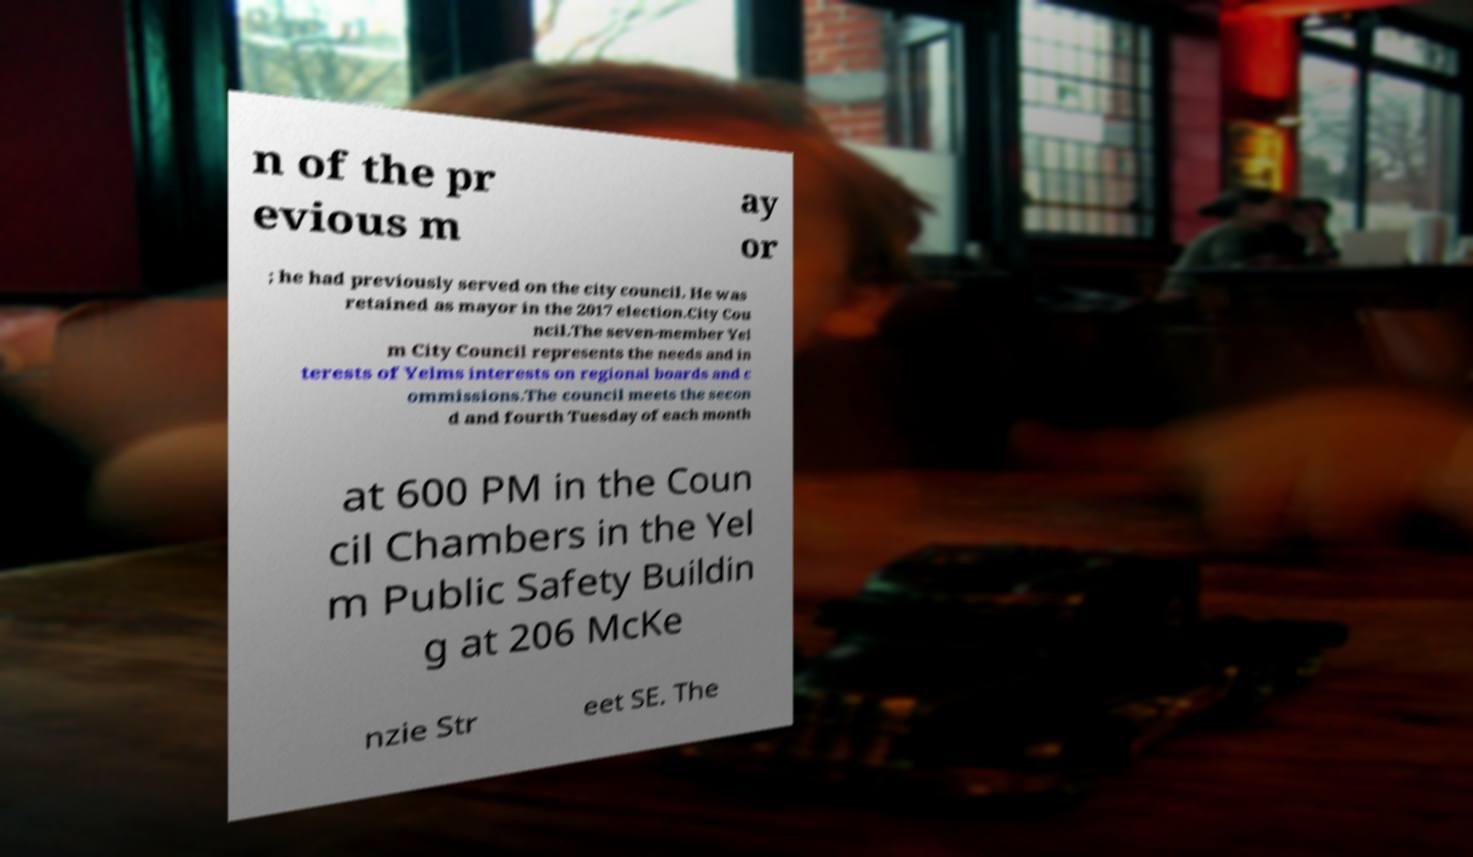Can you read and provide the text displayed in the image?This photo seems to have some interesting text. Can you extract and type it out for me? n of the pr evious m ay or ; he had previously served on the city council. He was retained as mayor in the 2017 election.City Cou ncil.The seven-member Yel m City Council represents the needs and in terests of Yelms interests on regional boards and c ommissions.The council meets the secon d and fourth Tuesday of each month at 600 PM in the Coun cil Chambers in the Yel m Public Safety Buildin g at 206 McKe nzie Str eet SE. The 